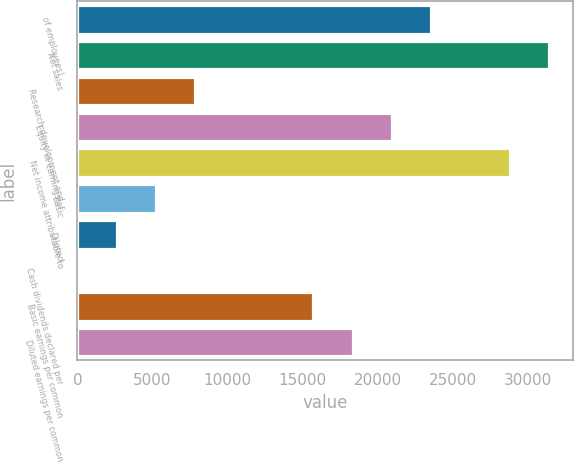<chart> <loc_0><loc_0><loc_500><loc_500><bar_chart><fcel>of employees)<fcel>Net sales<fcel>Research development and<fcel>Equity in earnings of<fcel>Net income attributable to<fcel>Basic<fcel>Diluted<fcel>Cash dividends declared per<fcel>Basic earnings per common<fcel>Diluted earnings per common<nl><fcel>23580<fcel>31440<fcel>7860.14<fcel>20960<fcel>28820<fcel>5240.16<fcel>2620.18<fcel>0.2<fcel>15720.1<fcel>18340.1<nl></chart> 